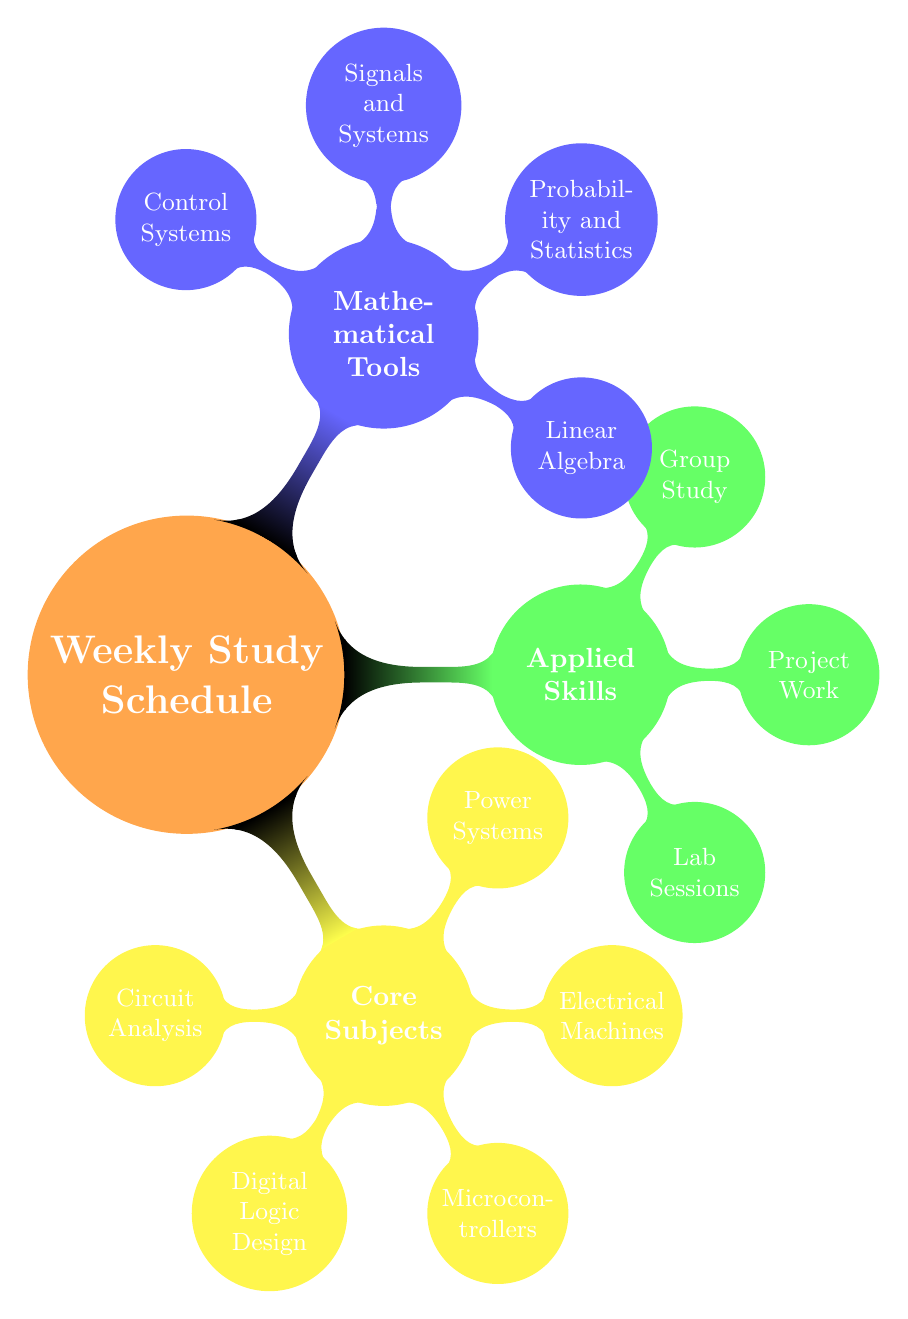What is the core subject scheduled for Monday morning? The diagram specifically lists "Circuit Analysis" under the Monday morning segment, which is categorized under Core Subjects.
Answer: Circuit Analysis How many core subjects are there in total? By counting the nodes under the Core Subjects section of the diagram, there are five core subjects listed: Circuit Analysis, Digital Logic Design, Microcontrollers, Electrical Machines, and Power Systems.
Answer: 5 What applied skill is scheduled for Friday evening? The evening slot on Friday is dedicated to "Group Study," which falls under the Applied Skills category.
Answer: Group Study Which mathematical tool is focused on during Thursday afternoon? The Thursday afternoon slot lists "Signals and Systems," which is categorized as a Mathematical Tool.
Answer: Signals and Systems What is the relationship between Core Subjects and Applied Skills as per the diagram? The Core Subjects are the main subjects of focus within the weekly schedule, while the Applied Skills include practical aspects like lab sessions and group study that support learning in those core subjects. Thus, they complement each other.
Answer: Complementary What type of session is scheduled for Tuesday evening? The diagram indicates that the session scheduled for Tuesday evening is a "Lab Session," under the Applied Skills category, focusing on hands-on experience with Logic Gates.
Answer: Lab Session Which day has a focus on revision? On Sunday morning, the schedule lists "Revision" as the key focus area.
Answer: Sunday How many nodes are in the Mathematical Tools section? The Mathematical Tools section includes four nodes: Linear Algebra, Probability and Statistics, Signals and Systems, and Control Systems. Counting these gives a total of four nodes.
Answer: 4 What is the focus area for Saturday morning? The Saturday morning segment is dedicated to "Renewable Energy Systems," which is classified as a Core Subject in the schedule.
Answer: Renewable Energy Systems 